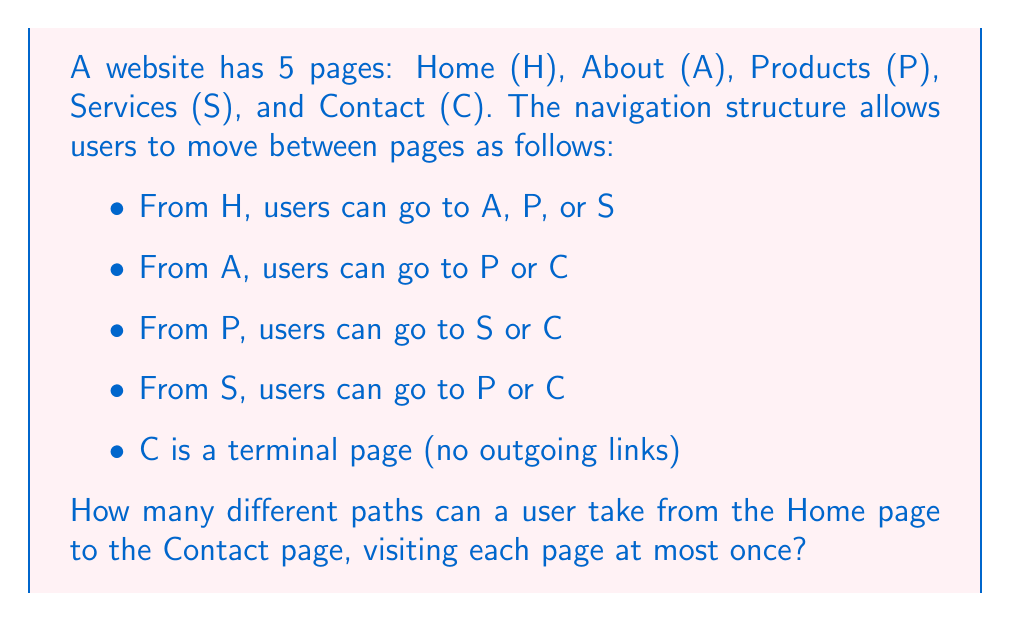Could you help me with this problem? Let's approach this step-by-step:

1) First, we need to identify all possible paths from H to C:
   - H → A → C
   - H → A → P → C
   - H → A → P → S → C
   - H → P → C
   - H → P → S → C
   - H → S → C
   - H → S → P → C

2) Now, let's count these paths:
   $$\text{Total paths} = 7$$

3) We can verify this result using the following method:
   - Paths of length 2: H → A → C (1 path)
   - Paths of length 3: H → A → P → C, H → P → C, H → S → C (3 paths)
   - Paths of length 4: H → A → P → S → C, H → P → S → C, H → S → P → C (3 paths)

4) Sum of all paths: $1 + 3 + 3 = 7$

This confirms our initial count.
Answer: 7 paths 